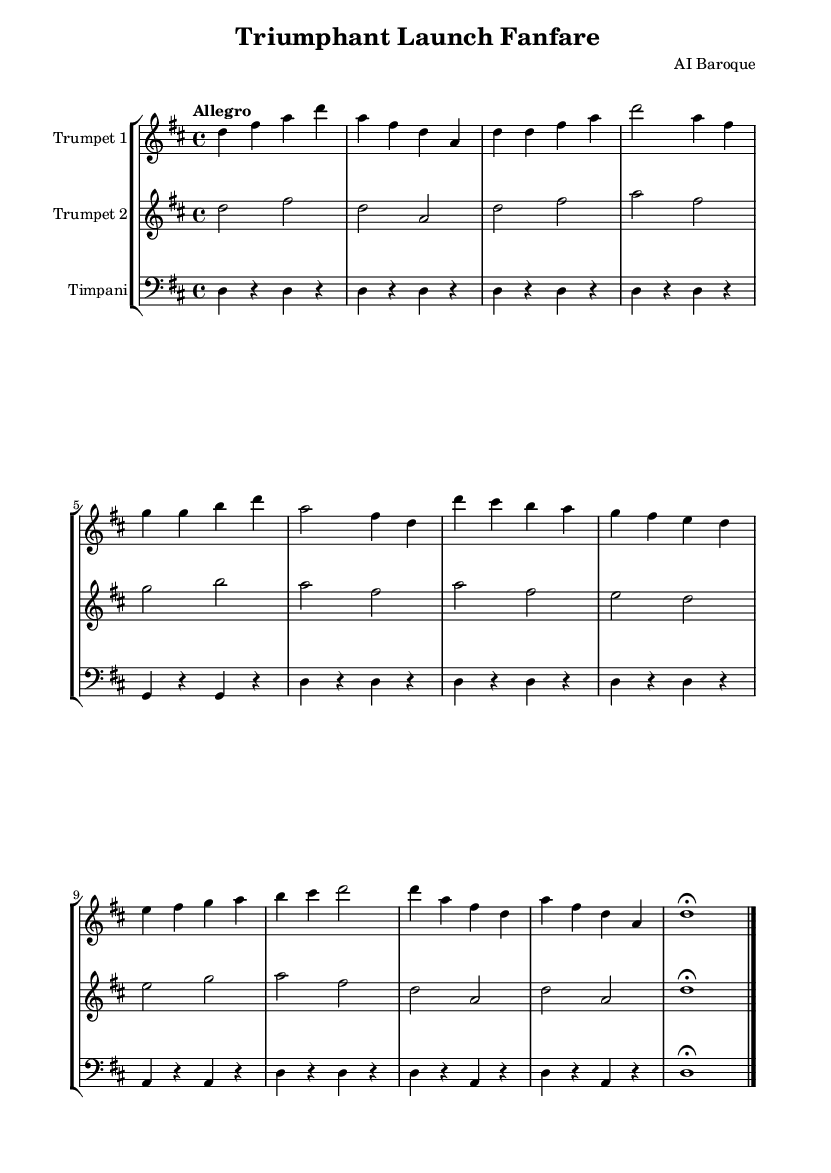What is the key signature of this music? The key signature is D major, indicated by two sharps which are F# and C#. This can be seen at the beginning of the score, right after the clef.
Answer: D major What is the time signature of this music? The time signature is 4/4, which is indicated after the key signature. It means there are four beats per measure, with each beat being a quarter note.
Answer: 4/4 What is the tempo marking of this music? The tempo marking is "Allegro," which is typically a fast tempo. It is indicated at the beginning of the score beneath the global settings.
Answer: Allegro How many measures are in the main theme section? The main theme consists of four measures. By counting the number of measures in the trumpet parts corresponding to the main theme, it's clear that it spans from the start of the theme section to its end.
Answer: 4 What is the instrumentation used in this piece? The instrumentation includes two trumpet parts and timpani. This information can be gathered from the staff group and the specific labels for each instrument at the start of their respective staves.
Answer: Trumpet 1, Trumpet 2, Timpani Which note is used to conclude the piece? The concluding note is D. This can be identified in the last measure where the note is held for a duration of one whole note, and it is marked with a fermata.
Answer: D What type of musical form is represented in this sheet music? The form is a fanfare, characterized by the use of bold and bright trumpet melodies with a strong rhythmic structure, typical of celebratory pieces in the Baroque style.
Answer: Fanfare 